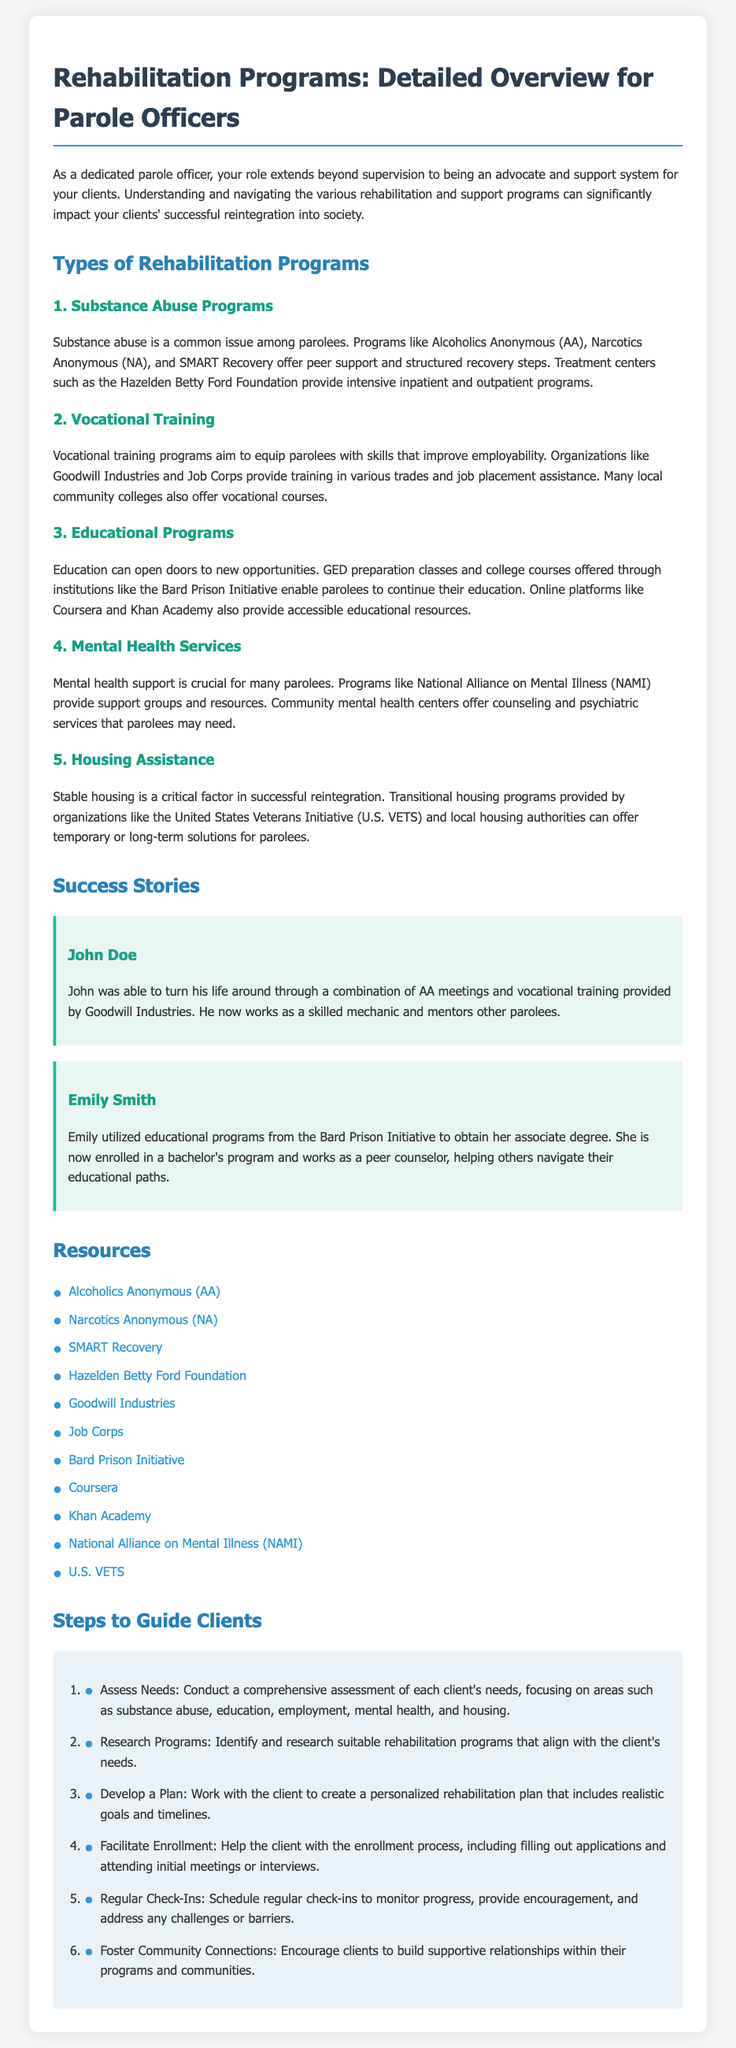What are the five types of rehabilitation programs mentioned? The document outlines five types of rehabilitation programs: Substance Abuse Programs, Vocational Training, Educational Programs, Mental Health Services, and Housing Assistance.
Answer: Substance Abuse Programs, Vocational Training, Educational Programs, Mental Health Services, Housing Assistance Who is John Doe? John Doe is a success story highlighted in the document, showcasing an individual who turned his life around through AA meetings and vocational training.
Answer: John Doe What organization offers job placement assistance along with vocational training? The document mentions Goodwill Industries as an organization that provides vocational training and job placement assistance for parolees.
Answer: Goodwill Industries How many success stories are provided in the document? The document includes two success stories, one for John Doe and one for Emily Smith, illustrating their achievements after rehabilitation programs.
Answer: Two What is the first step to guide clients through rehabilitation programs? The first step outlined for guiding clients is to conduct a comprehensive assessment of each client's needs.
Answer: Assess Needs Which program helps parolees obtain their associate degrees? The Bard Prison Initiative is mentioned as a program that assists parolees in obtaining their associate degrees.
Answer: Bard Prison Initiative What resource is linked to support for mental health issues? The National Alliance on Mental Illness (NAMI) is a resource mentioned in the document that provides support for mental health issues.
Answer: National Alliance on Mental Illness (NAMI) What type of support do organizations like U.S. VETS provide? The document states that U.S. VETS provides transitional housing programs for parolees.
Answer: Transitional housing programs What is emphasized as critical for successful reintegration? The document emphasizes stable housing as a critical factor for successful reintegration of parolees into society.
Answer: Stable housing 